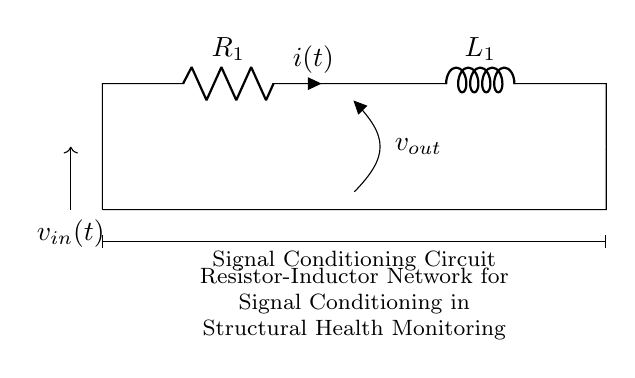What is the value of the resistor in this circuit? The circuit diagram labels the resistor as R1, but does not provide a numerical value. Hence, we cannot ascertain the specific resistance value just from the diagram.
Answer: R1 What type of inductor is used in this circuit? The circuit diagram indicates the presence of an inductor (L1), but it does not specify the type or characteristics of the inductor. Thus, the type remains undefined based on the diagram.
Answer: L1 What is the current flowing through the resistor? The diagram identifies the current through the resistor as i(t), but does not provide a specific value or function for it. Therefore, the current is represented generically without a specific numerical value.
Answer: i(t) What is the purpose of the resistor-inductor network in this context? The diagram includes a note stating that this is a "Resistor-Inductor Network for Signal Conditioning in Structural Health Monitoring." This indicates that the network is likely used to filter or process signals from structural monitoring devices.
Answer: Signal conditioning How does the configuration of the resistor and inductor affect the circuit's response? The resistor and inductor are in series in this circuit configuration, which creates an RL circuit. This arrangement affects the impedance, time constant, and frequency response, influencing how the circuit responds to input signals. Specifically, it can introduce phase shifts and frequency-dependent attenuation, affecting the outputs used in health monitoring.
Answer: Affects impedance and response What is the output voltage relative to the input voltage? The output voltage, represented as v(out), is dependent on the resistor and inductor values and their arrangement. The relationship can be determined using circuit analysis techniques like voltage division or analyzing the RL time constant. However, it's not specified in the diagram directly.
Answer: Depends on R1 and L1 